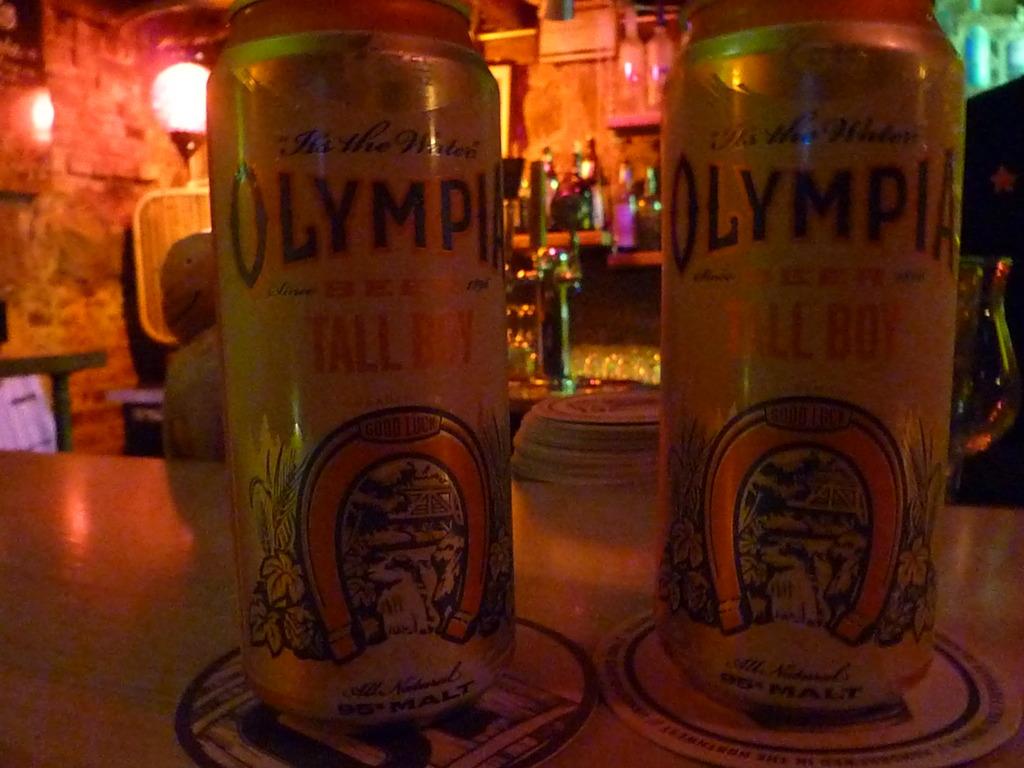What is the name of this olympia drink?
Give a very brief answer. Tall boy. Is this a public place?
Make the answer very short. Answering does not require reading text in the image. 